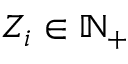Convert formula to latex. <formula><loc_0><loc_0><loc_500><loc_500>Z _ { i } \in \mathbb { N } _ { + }</formula> 